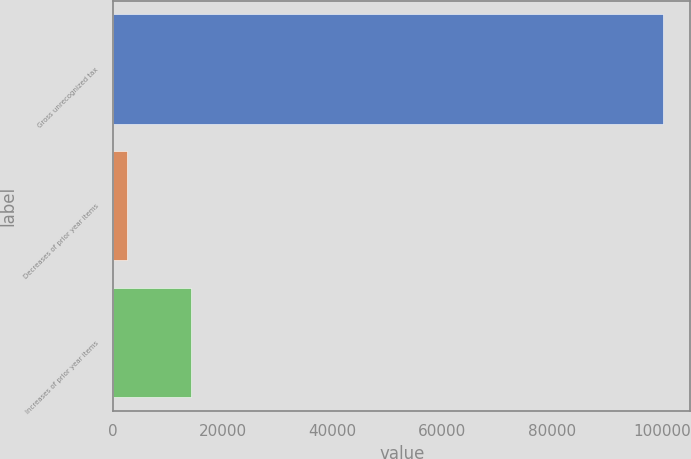<chart> <loc_0><loc_0><loc_500><loc_500><bar_chart><fcel>Gross unrecognized tax<fcel>Decreases of prior year items<fcel>Increases of prior year items<nl><fcel>100168<fcel>2605<fcel>14213<nl></chart> 